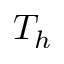<formula> <loc_0><loc_0><loc_500><loc_500>T _ { h }</formula> 